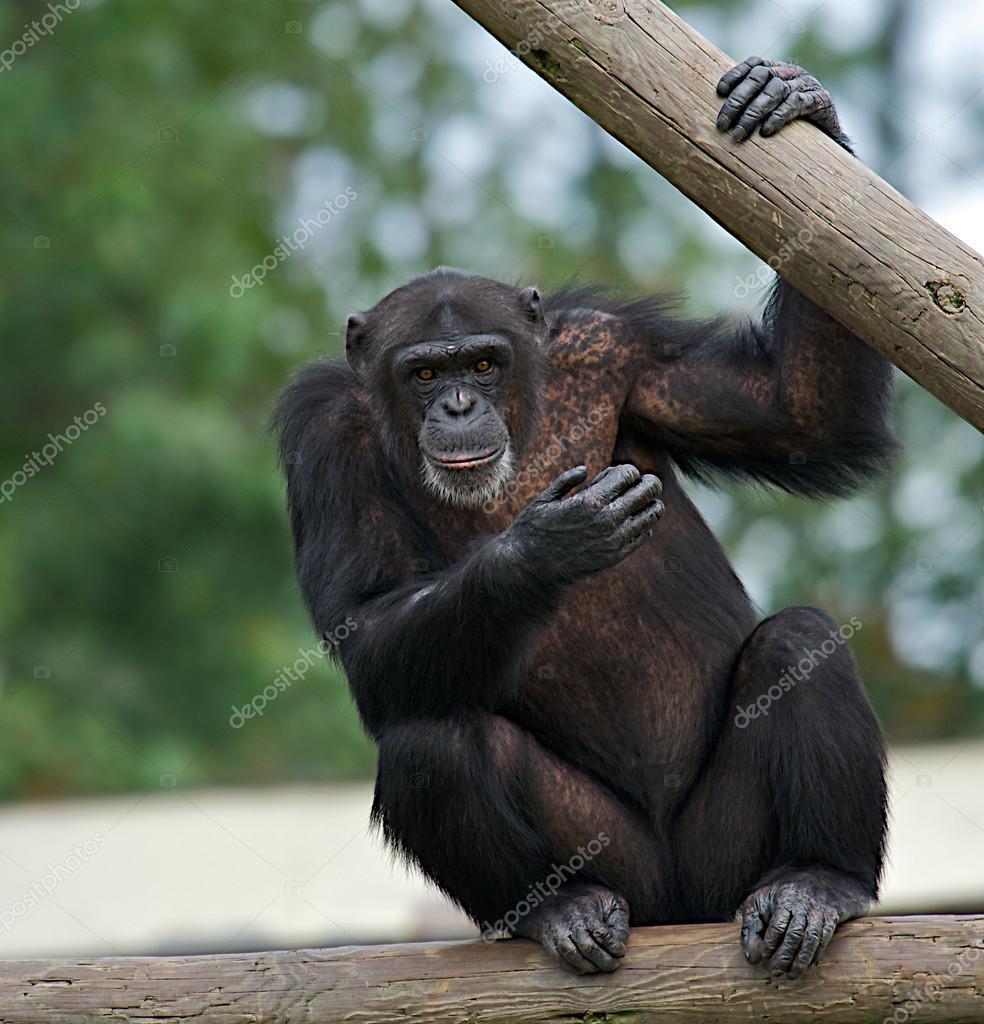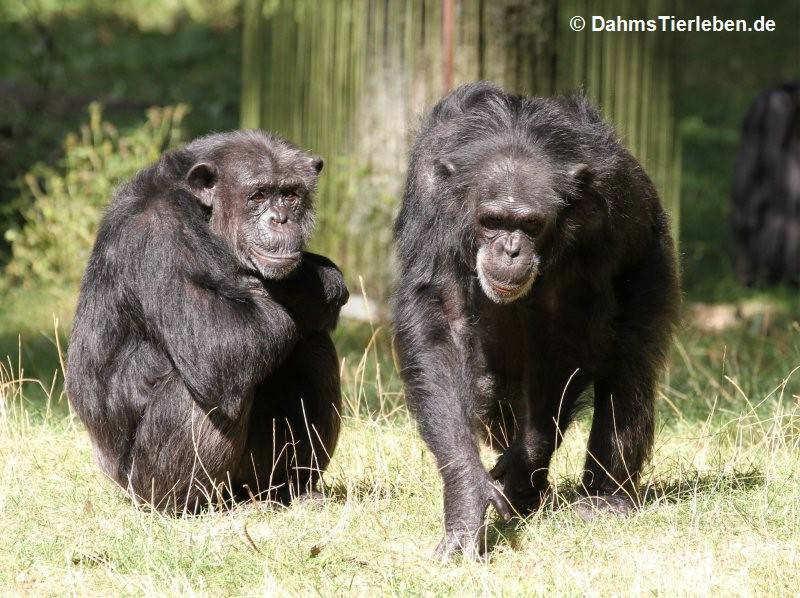The first image is the image on the left, the second image is the image on the right. Given the left and right images, does the statement "An image shows one non-sleeping chimp, which is perched on a wooden object." hold true? Answer yes or no. Yes. 